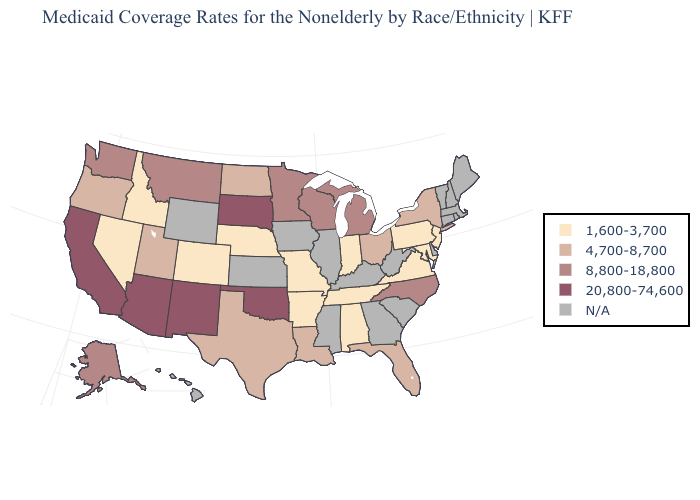How many symbols are there in the legend?
Quick response, please. 5. What is the value of Pennsylvania?
Quick response, please. 1,600-3,700. What is the highest value in the MidWest ?
Short answer required. 20,800-74,600. Name the states that have a value in the range 20,800-74,600?
Answer briefly. Arizona, California, New Mexico, Oklahoma, South Dakota. What is the highest value in states that border Nevada?
Keep it brief. 20,800-74,600. Does North Carolina have the highest value in the USA?
Answer briefly. No. Does New York have the lowest value in the Northeast?
Give a very brief answer. No. Is the legend a continuous bar?
Give a very brief answer. No. What is the value of Louisiana?
Write a very short answer. 4,700-8,700. What is the value of California?
Answer briefly. 20,800-74,600. What is the highest value in states that border Wisconsin?
Give a very brief answer. 8,800-18,800. Among the states that border Kentucky , which have the lowest value?
Concise answer only. Indiana, Missouri, Tennessee, Virginia. Which states hav the highest value in the South?
Concise answer only. Oklahoma. What is the highest value in the MidWest ?
Quick response, please. 20,800-74,600. 